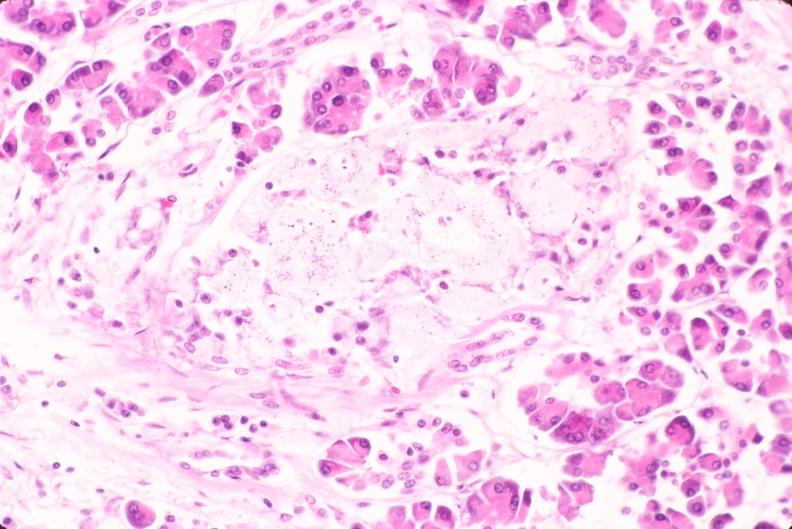where is this part in the figure?
Answer the question using a single word or phrase. Endocrine system 